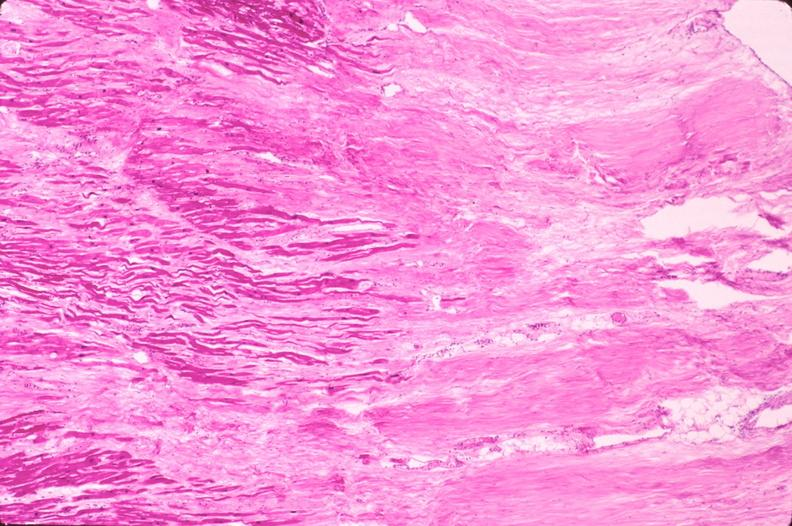does this image show heart, myocardial infarction free wall, 6 days old, in a patient with diabetes mellitus and hypertension?
Answer the question using a single word or phrase. Yes 